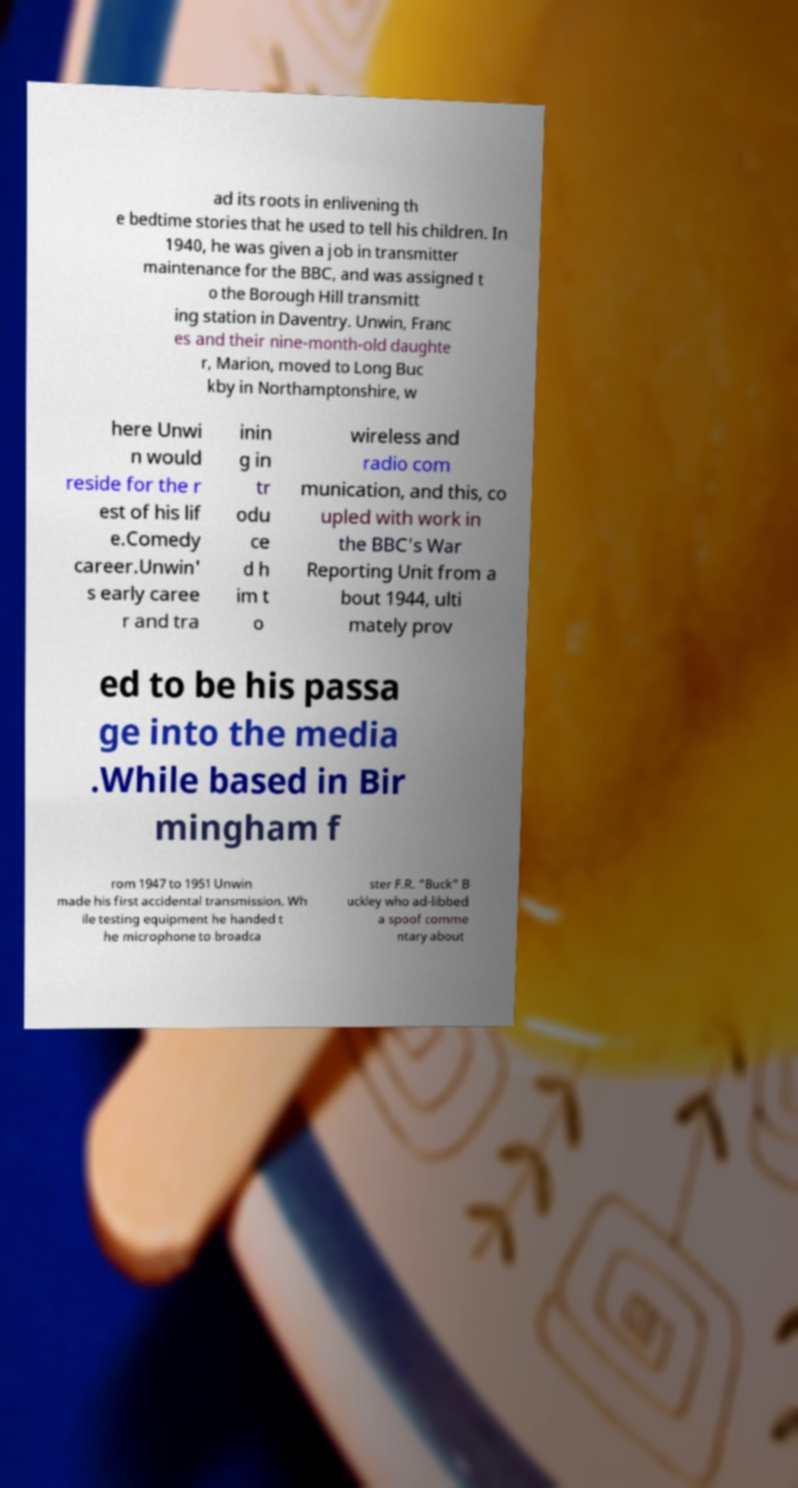Can you read and provide the text displayed in the image?This photo seems to have some interesting text. Can you extract and type it out for me? ad its roots in enlivening th e bedtime stories that he used to tell his children. In 1940, he was given a job in transmitter maintenance for the BBC, and was assigned t o the Borough Hill transmitt ing station in Daventry. Unwin, Franc es and their nine-month-old daughte r, Marion, moved to Long Buc kby in Northamptonshire, w here Unwi n would reside for the r est of his lif e.Comedy career.Unwin' s early caree r and tra inin g in tr odu ce d h im t o wireless and radio com munication, and this, co upled with work in the BBC's War Reporting Unit from a bout 1944, ulti mately prov ed to be his passa ge into the media .While based in Bir mingham f rom 1947 to 1951 Unwin made his first accidental transmission. Wh ile testing equipment he handed t he microphone to broadca ster F.R. "Buck" B uckley who ad-libbed a spoof comme ntary about 